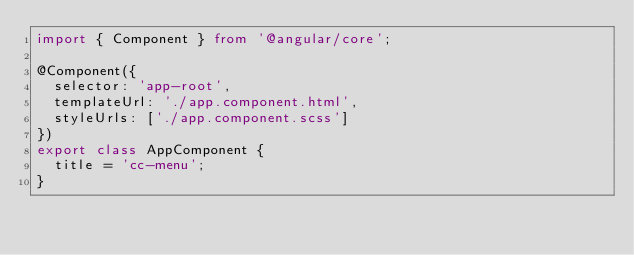<code> <loc_0><loc_0><loc_500><loc_500><_TypeScript_>import { Component } from '@angular/core';

@Component({
  selector: 'app-root',
  templateUrl: './app.component.html',
  styleUrls: ['./app.component.scss']
})
export class AppComponent {
  title = 'cc-menu';
}
</code> 